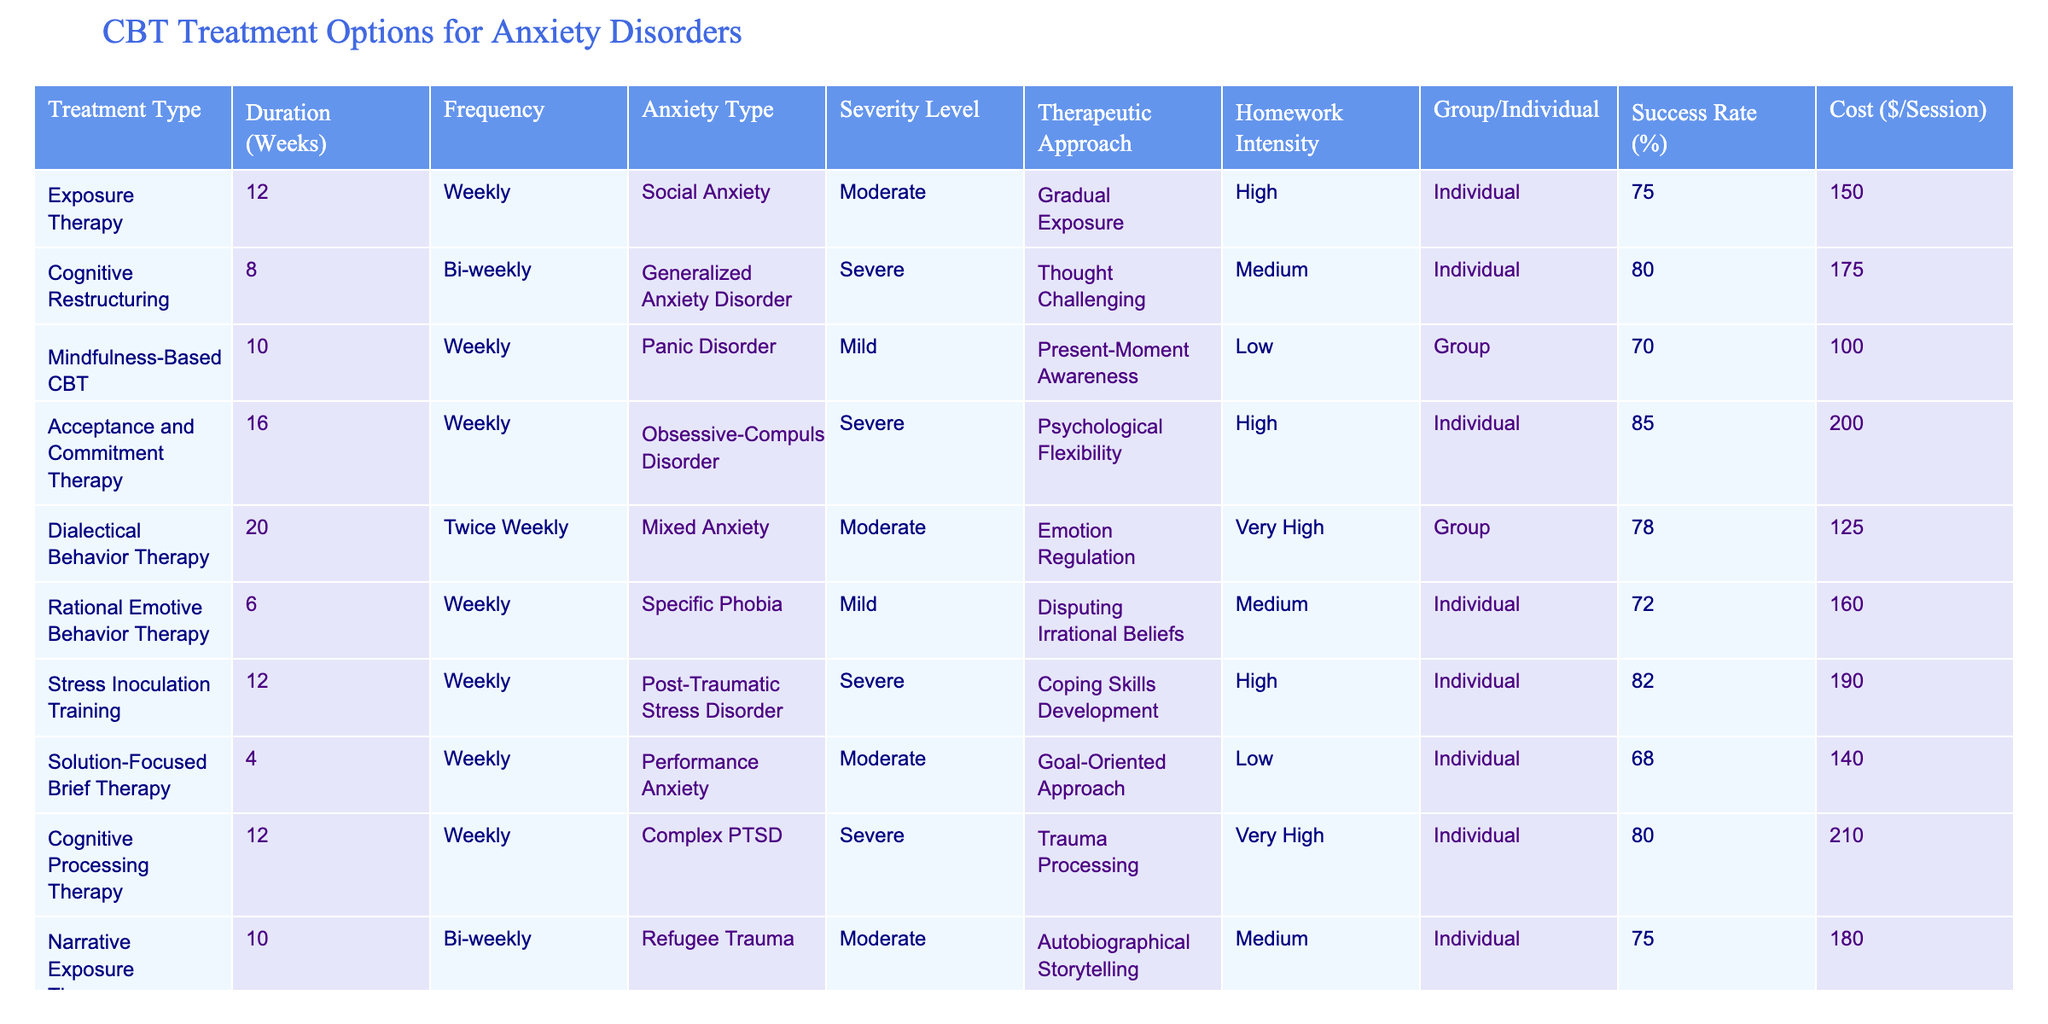What is the success rate of Acceptance and Commitment Therapy? The table clearly indicates that the success rate for Acceptance and Commitment Therapy is listed as 85%.
Answer: 85% Which treatment has the highest cost per session? Upon reviewing the cost per session column, I find that Cognitive Processing Therapy has the highest cost at $210 per session.
Answer: $210 What is the average duration of treatments for severe anxiety disorders? The treatments for severe anxiety disorders are Cognitive Restructuring (8 weeks), Acceptance and Commitment Therapy (16 weeks), and Stress Inoculation Training (12 weeks). The average duration is (8 + 16 + 12) / 3 = 36 / 3 = 12 weeks.
Answer: 12 weeks Is Mindfulness-Based CBT more frequently conducted in a group or individual setting? Mindfulness-Based CBT is listed as a group treatment in the table, making this a straightforward yes.
Answer: Yes Which treatment option has the lowest success rate? By looking across the success rate column, Solution-Focused Brief Therapy has the lowest success rate at 68%.
Answer: 68% How many treatments have a high homework intensity? Analyzing the homework intensity column, the treatments with high homework intensity are Exposure Therapy, Acceptance and Commitment Therapy, and Stress Inoculation Training. This totals three treatments with high homework intensity.
Answer: 3 Which anxiety type has the longest treatment duration? The table indicates Acceptance and Commitment Therapy is for Obsessive-Compulsive Disorder and has the longest duration of 16 weeks.
Answer: 16 weeks Does Exposure Therapy employ a group or individual format? It lists in the table that Exposure Therapy is conducted in an individual setting, confirming the format is individual.
Answer: Individual What is the difference in success rates between Cognitive Restructuring and Mindfulness-Based CBT? Cognitive Restructuring has a success rate of 80%, and Mindfulness-Based CBT has a success rate of 70%. The difference is 80 - 70 = 10%, indicating that Cognitive Restructuring is more effective by this margin.
Answer: 10% 